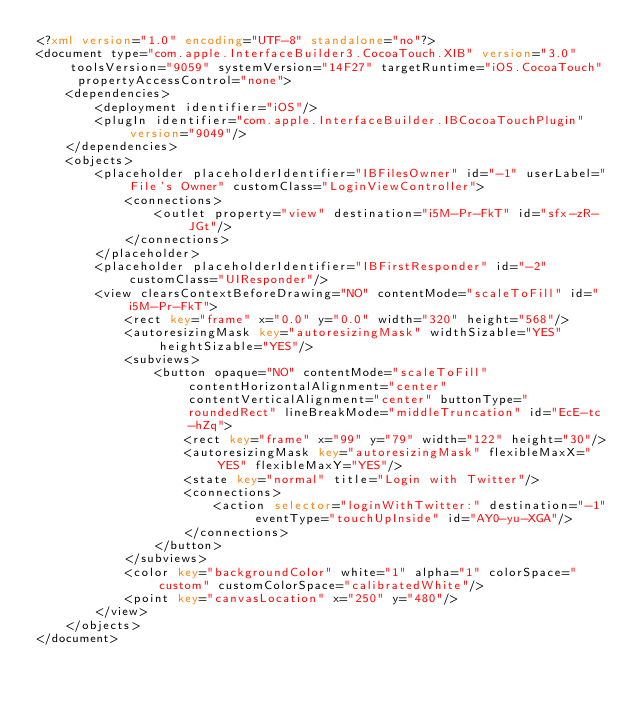<code> <loc_0><loc_0><loc_500><loc_500><_XML_><?xml version="1.0" encoding="UTF-8" standalone="no"?>
<document type="com.apple.InterfaceBuilder3.CocoaTouch.XIB" version="3.0" toolsVersion="9059" systemVersion="14F27" targetRuntime="iOS.CocoaTouch" propertyAccessControl="none">
    <dependencies>
        <deployment identifier="iOS"/>
        <plugIn identifier="com.apple.InterfaceBuilder.IBCocoaTouchPlugin" version="9049"/>
    </dependencies>
    <objects>
        <placeholder placeholderIdentifier="IBFilesOwner" id="-1" userLabel="File's Owner" customClass="LoginViewController">
            <connections>
                <outlet property="view" destination="i5M-Pr-FkT" id="sfx-zR-JGt"/>
            </connections>
        </placeholder>
        <placeholder placeholderIdentifier="IBFirstResponder" id="-2" customClass="UIResponder"/>
        <view clearsContextBeforeDrawing="NO" contentMode="scaleToFill" id="i5M-Pr-FkT">
            <rect key="frame" x="0.0" y="0.0" width="320" height="568"/>
            <autoresizingMask key="autoresizingMask" widthSizable="YES" heightSizable="YES"/>
            <subviews>
                <button opaque="NO" contentMode="scaleToFill" contentHorizontalAlignment="center" contentVerticalAlignment="center" buttonType="roundedRect" lineBreakMode="middleTruncation" id="EcE-tc-hZq">
                    <rect key="frame" x="99" y="79" width="122" height="30"/>
                    <autoresizingMask key="autoresizingMask" flexibleMaxX="YES" flexibleMaxY="YES"/>
                    <state key="normal" title="Login with Twitter"/>
                    <connections>
                        <action selector="loginWithTwitter:" destination="-1" eventType="touchUpInside" id="AY0-yu-XGA"/>
                    </connections>
                </button>
            </subviews>
            <color key="backgroundColor" white="1" alpha="1" colorSpace="custom" customColorSpace="calibratedWhite"/>
            <point key="canvasLocation" x="250" y="480"/>
        </view>
    </objects>
</document>
</code> 